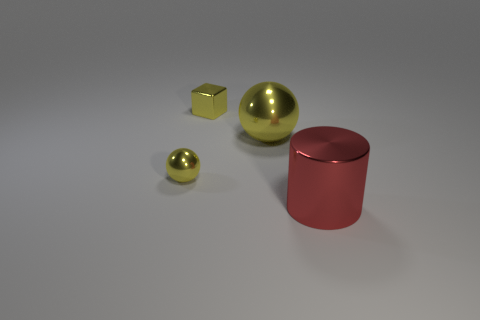Add 4 spheres. How many objects exist? 8 Subtract all cylinders. How many objects are left? 3 Add 4 big yellow shiny things. How many big yellow shiny things exist? 5 Subtract 0 purple cylinders. How many objects are left? 4 Subtract all yellow metallic blocks. Subtract all big red shiny cylinders. How many objects are left? 2 Add 2 metal things. How many metal things are left? 6 